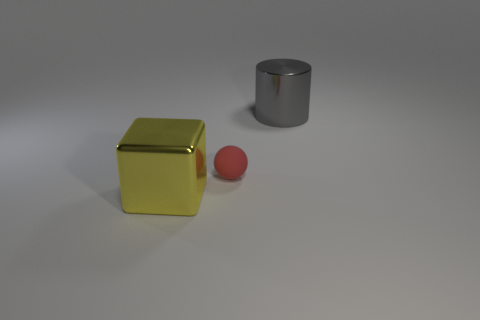What number of other large shiny objects have the same shape as the big yellow shiny thing?
Make the answer very short. 0. What shape is the large yellow object that is to the left of the big shiny object to the right of the large object to the left of the red rubber sphere?
Your answer should be very brief. Cube. There is a thing that is behind the big block and to the left of the gray metal cylinder; what material is it?
Your response must be concise. Rubber. Does the shiny thing behind the yellow shiny block have the same size as the yellow metal cube?
Keep it short and to the point. Yes. Is there anything else that has the same size as the gray metal cylinder?
Offer a terse response. Yes. Is the number of red rubber spheres to the left of the small red thing greater than the number of yellow cubes that are right of the big gray shiny thing?
Offer a very short reply. No. There is a large metal thing to the right of the large thing that is left of the big thing right of the ball; what is its color?
Offer a terse response. Gray. Does the shiny cylinder that is on the right side of the matte ball have the same color as the cube?
Your answer should be very brief. No. What number of other things are there of the same color as the metallic cylinder?
Provide a short and direct response. 0. What number of things are either gray things or cyan metallic things?
Keep it short and to the point. 1. 